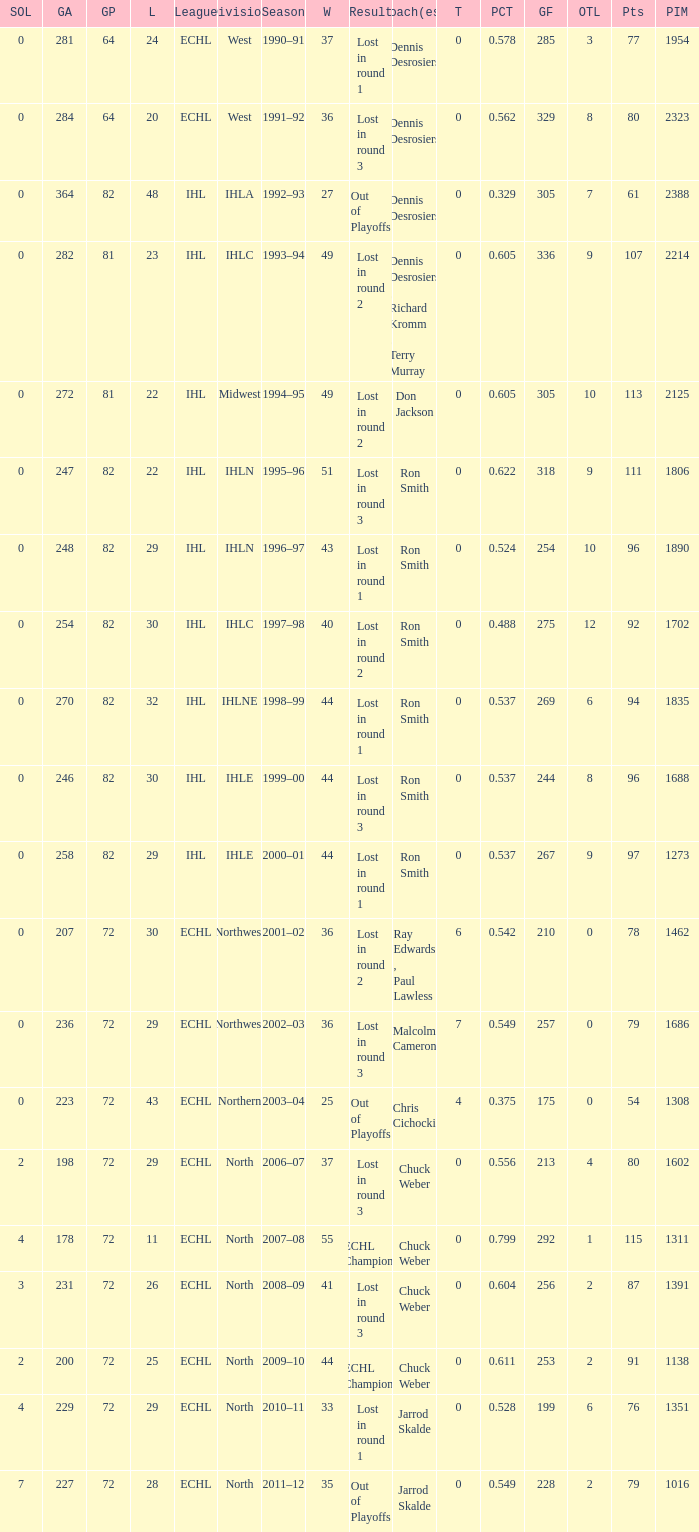How many season did the team lost in round 1 with a GP of 64? 1.0. 